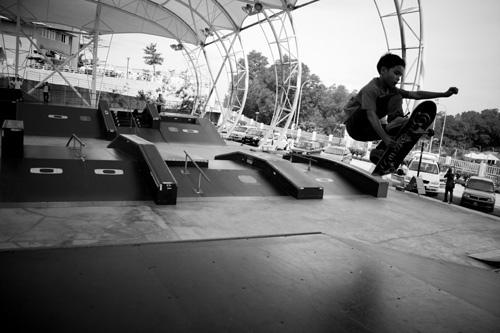What is the kid doing?
Give a very brief answer. Skateboarding. Why is the child's arm up?
Quick response, please. Balance. Is the picture in color?
Keep it brief. No. 